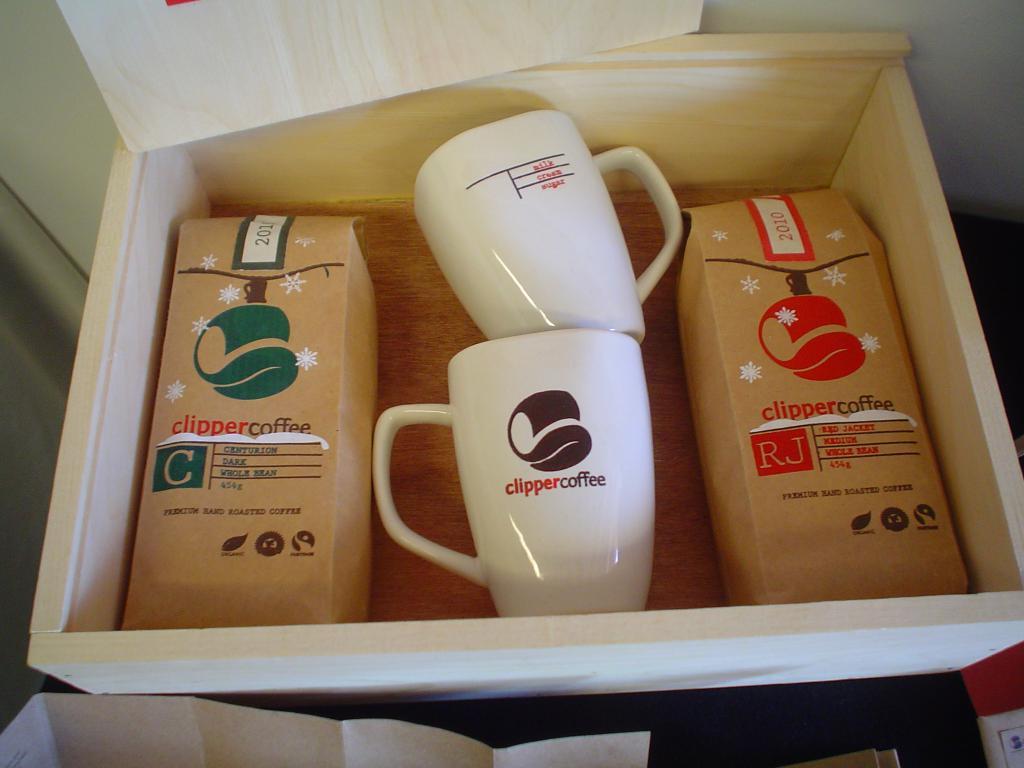Where are the mugs from?
Provide a short and direct response. Clipper coffee. What is the type of coffee?
Your answer should be compact. Clipper. 